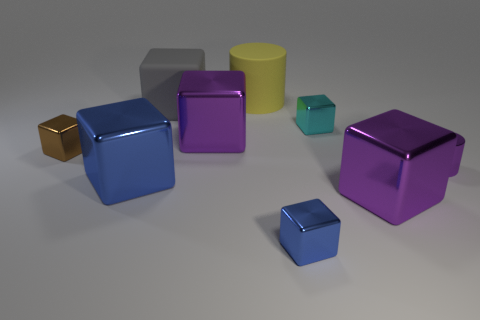Is there a big yellow thing of the same shape as the tiny purple thing?
Your answer should be compact. Yes. The tiny thing in front of the small purple metal cylinder has what shape?
Provide a short and direct response. Cube. How many tiny purple objects are there?
Offer a very short reply. 1. There is a cylinder that is the same material as the tiny cyan cube; what is its color?
Your answer should be very brief. Purple. How many tiny things are either blue metal objects or purple rubber cubes?
Provide a short and direct response. 1. There is a big blue shiny object; what number of large purple shiny objects are in front of it?
Keep it short and to the point. 1. The other small object that is the same shape as the yellow rubber thing is what color?
Keep it short and to the point. Purple. How many matte objects are tiny cyan things or large yellow things?
Provide a short and direct response. 1. Are there any large objects that are right of the large purple shiny cube that is left of the big purple metallic thing that is in front of the shiny cylinder?
Your response must be concise. Yes. What color is the small cylinder?
Give a very brief answer. Purple. 